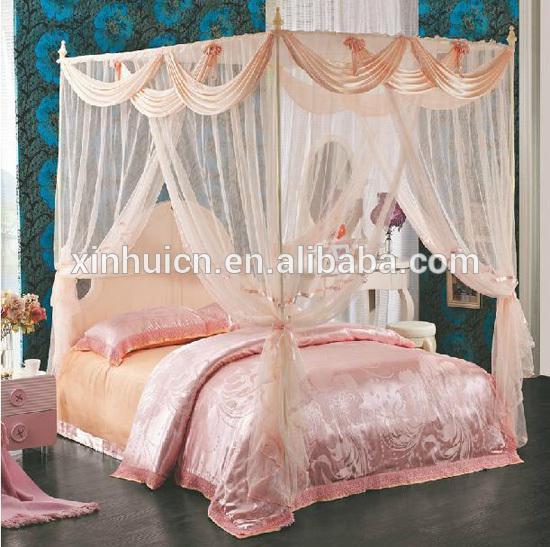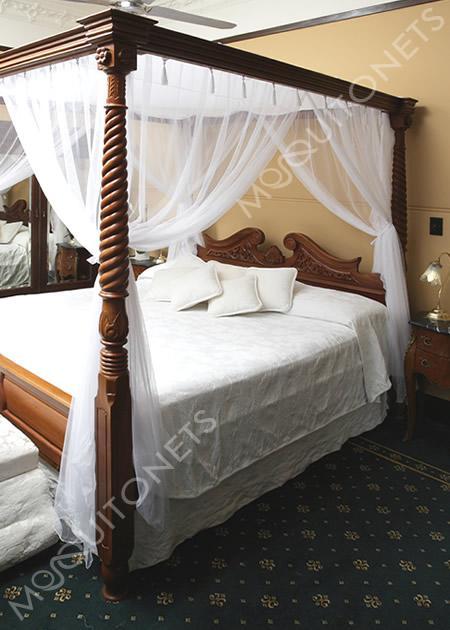The first image is the image on the left, the second image is the image on the right. Assess this claim about the two images: "The bedposts in one image have a draping that is lavender.". Correct or not? Answer yes or no. No. The first image is the image on the left, the second image is the image on the right. Evaluate the accuracy of this statement regarding the images: "An image shows a four-posted bed decorated with a curtain-tied lavender canopy.". Is it true? Answer yes or no. No. 